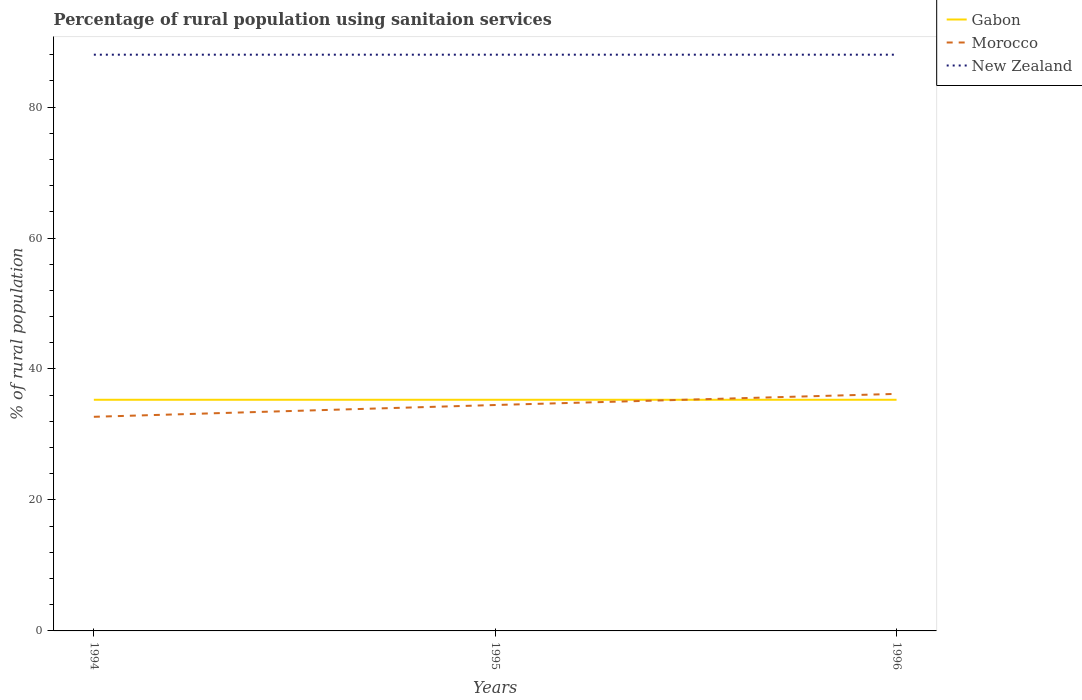Is the number of lines equal to the number of legend labels?
Provide a succinct answer. Yes. Across all years, what is the maximum percentage of rural population using sanitaion services in Gabon?
Provide a short and direct response. 35.3. What is the difference between the highest and the second highest percentage of rural population using sanitaion services in New Zealand?
Your answer should be compact. 0. Is the percentage of rural population using sanitaion services in Gabon strictly greater than the percentage of rural population using sanitaion services in Morocco over the years?
Your answer should be compact. No. How many lines are there?
Make the answer very short. 3. How many years are there in the graph?
Ensure brevity in your answer.  3. What is the difference between two consecutive major ticks on the Y-axis?
Ensure brevity in your answer.  20. Does the graph contain grids?
Offer a terse response. No. How are the legend labels stacked?
Provide a succinct answer. Vertical. What is the title of the graph?
Give a very brief answer. Percentage of rural population using sanitaion services. What is the label or title of the Y-axis?
Keep it short and to the point. % of rural population. What is the % of rural population in Gabon in 1994?
Ensure brevity in your answer.  35.3. What is the % of rural population of Morocco in 1994?
Keep it short and to the point. 32.7. What is the % of rural population of Gabon in 1995?
Offer a terse response. 35.3. What is the % of rural population of Morocco in 1995?
Make the answer very short. 34.5. What is the % of rural population in New Zealand in 1995?
Keep it short and to the point. 88. What is the % of rural population in Gabon in 1996?
Offer a very short reply. 35.3. What is the % of rural population in Morocco in 1996?
Your answer should be compact. 36.2. What is the % of rural population of New Zealand in 1996?
Provide a short and direct response. 88. Across all years, what is the maximum % of rural population of Gabon?
Ensure brevity in your answer.  35.3. Across all years, what is the maximum % of rural population of Morocco?
Your answer should be very brief. 36.2. Across all years, what is the maximum % of rural population of New Zealand?
Your response must be concise. 88. Across all years, what is the minimum % of rural population in Gabon?
Your answer should be compact. 35.3. Across all years, what is the minimum % of rural population of Morocco?
Provide a succinct answer. 32.7. Across all years, what is the minimum % of rural population of New Zealand?
Provide a short and direct response. 88. What is the total % of rural population of Gabon in the graph?
Your answer should be very brief. 105.9. What is the total % of rural population in Morocco in the graph?
Provide a succinct answer. 103.4. What is the total % of rural population in New Zealand in the graph?
Keep it short and to the point. 264. What is the difference between the % of rural population of Gabon in 1994 and that in 1996?
Make the answer very short. 0. What is the difference between the % of rural population in Morocco in 1994 and that in 1996?
Keep it short and to the point. -3.5. What is the difference between the % of rural population of Gabon in 1995 and that in 1996?
Your answer should be very brief. 0. What is the difference between the % of rural population of Morocco in 1995 and that in 1996?
Keep it short and to the point. -1.7. What is the difference between the % of rural population of New Zealand in 1995 and that in 1996?
Offer a very short reply. 0. What is the difference between the % of rural population in Gabon in 1994 and the % of rural population in Morocco in 1995?
Make the answer very short. 0.8. What is the difference between the % of rural population of Gabon in 1994 and the % of rural population of New Zealand in 1995?
Your answer should be compact. -52.7. What is the difference between the % of rural population in Morocco in 1994 and the % of rural population in New Zealand in 1995?
Provide a succinct answer. -55.3. What is the difference between the % of rural population of Gabon in 1994 and the % of rural population of Morocco in 1996?
Provide a short and direct response. -0.9. What is the difference between the % of rural population of Gabon in 1994 and the % of rural population of New Zealand in 1996?
Your answer should be compact. -52.7. What is the difference between the % of rural population of Morocco in 1994 and the % of rural population of New Zealand in 1996?
Offer a very short reply. -55.3. What is the difference between the % of rural population of Gabon in 1995 and the % of rural population of New Zealand in 1996?
Give a very brief answer. -52.7. What is the difference between the % of rural population of Morocco in 1995 and the % of rural population of New Zealand in 1996?
Your answer should be compact. -53.5. What is the average % of rural population of Gabon per year?
Your answer should be very brief. 35.3. What is the average % of rural population in Morocco per year?
Make the answer very short. 34.47. In the year 1994, what is the difference between the % of rural population of Gabon and % of rural population of Morocco?
Ensure brevity in your answer.  2.6. In the year 1994, what is the difference between the % of rural population in Gabon and % of rural population in New Zealand?
Your response must be concise. -52.7. In the year 1994, what is the difference between the % of rural population of Morocco and % of rural population of New Zealand?
Provide a succinct answer. -55.3. In the year 1995, what is the difference between the % of rural population in Gabon and % of rural population in New Zealand?
Keep it short and to the point. -52.7. In the year 1995, what is the difference between the % of rural population in Morocco and % of rural population in New Zealand?
Offer a terse response. -53.5. In the year 1996, what is the difference between the % of rural population in Gabon and % of rural population in New Zealand?
Ensure brevity in your answer.  -52.7. In the year 1996, what is the difference between the % of rural population in Morocco and % of rural population in New Zealand?
Offer a terse response. -51.8. What is the ratio of the % of rural population in Gabon in 1994 to that in 1995?
Your answer should be compact. 1. What is the ratio of the % of rural population in Morocco in 1994 to that in 1995?
Ensure brevity in your answer.  0.95. What is the ratio of the % of rural population of Gabon in 1994 to that in 1996?
Provide a short and direct response. 1. What is the ratio of the % of rural population of Morocco in 1994 to that in 1996?
Your response must be concise. 0.9. What is the ratio of the % of rural population of Gabon in 1995 to that in 1996?
Give a very brief answer. 1. What is the ratio of the % of rural population in Morocco in 1995 to that in 1996?
Provide a short and direct response. 0.95. What is the difference between the highest and the second highest % of rural population in Morocco?
Offer a terse response. 1.7. What is the difference between the highest and the lowest % of rural population of Gabon?
Your response must be concise. 0. What is the difference between the highest and the lowest % of rural population of Morocco?
Your response must be concise. 3.5. What is the difference between the highest and the lowest % of rural population of New Zealand?
Your answer should be very brief. 0. 